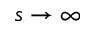Convert formula to latex. <formula><loc_0><loc_0><loc_500><loc_500>s \to \infty</formula> 